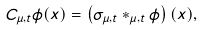Convert formula to latex. <formula><loc_0><loc_0><loc_500><loc_500>C _ { \mu , t } \phi ( x ) = \left ( \sigma _ { \mu , t } \ast _ { \mu , t } \phi \right ) ( x ) ,</formula> 